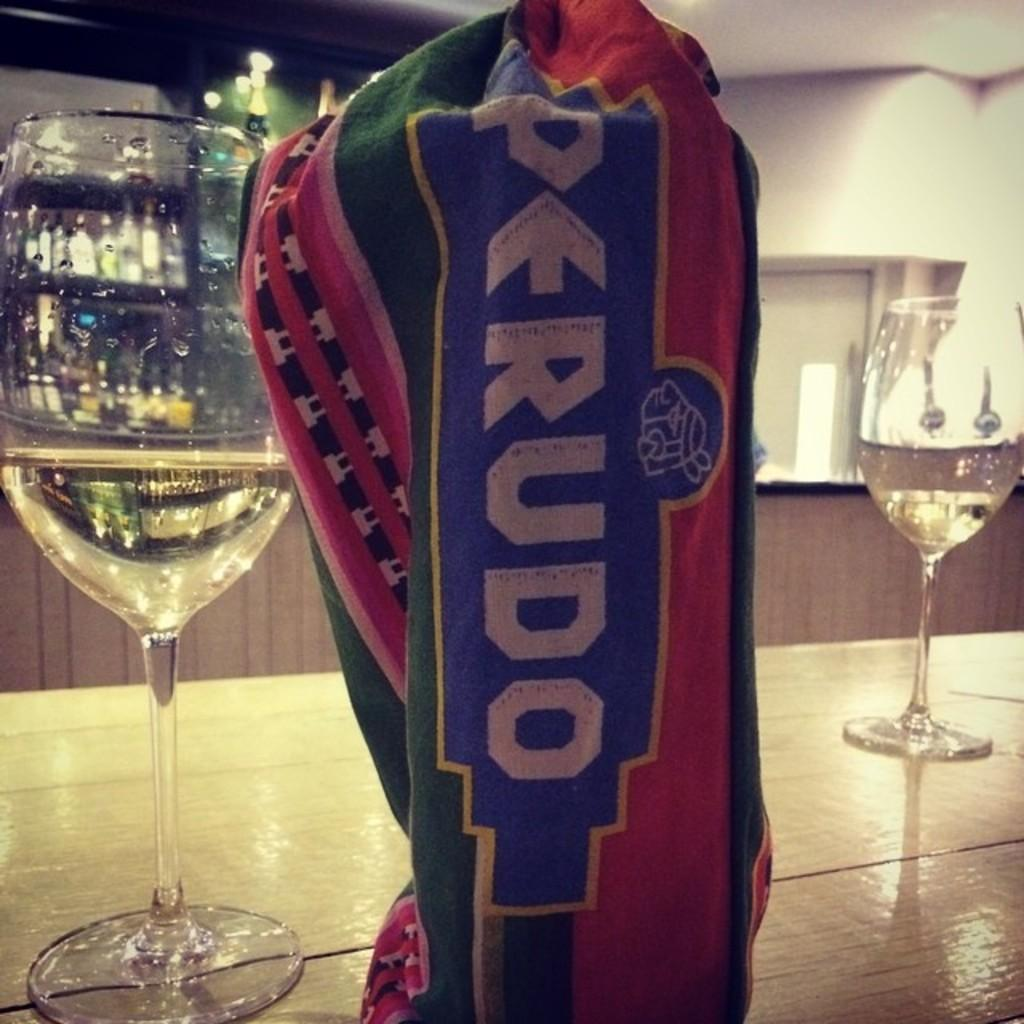<image>
Describe the image concisely. A shirt that says Perudo is wrapped around a glass on a bar. 